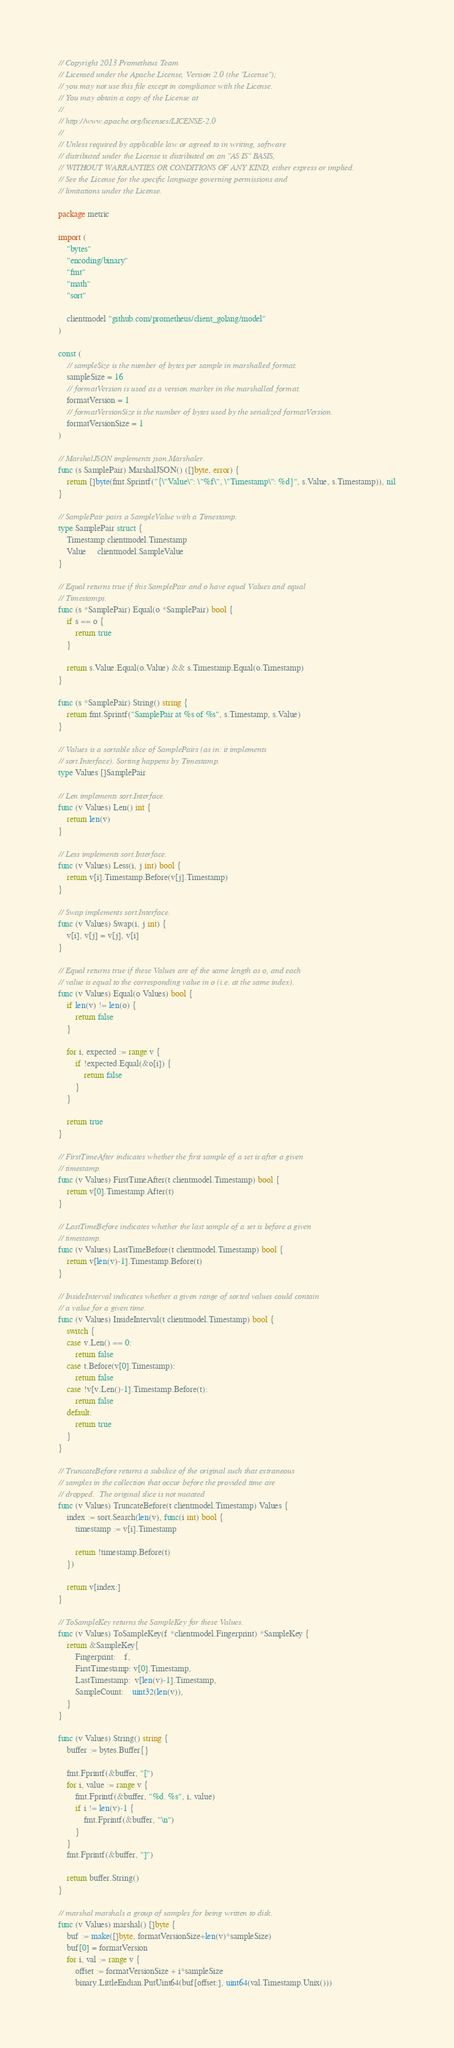<code> <loc_0><loc_0><loc_500><loc_500><_Go_>// Copyright 2013 Prometheus Team
// Licensed under the Apache License, Version 2.0 (the "License");
// you may not use this file except in compliance with the License.
// You may obtain a copy of the License at
//
// http://www.apache.org/licenses/LICENSE-2.0
//
// Unless required by applicable law or agreed to in writing, software
// distributed under the License is distributed on an "AS IS" BASIS,
// WITHOUT WARRANTIES OR CONDITIONS OF ANY KIND, either express or implied.
// See the License for the specific language governing permissions and
// limitations under the License.

package metric

import (
	"bytes"
	"encoding/binary"
	"fmt"
	"math"
	"sort"

	clientmodel "github.com/prometheus/client_golang/model"
)

const (
	// sampleSize is the number of bytes per sample in marshalled format.
	sampleSize = 16
	// formatVersion is used as a version marker in the marshalled format.
	formatVersion = 1
	// formatVersionSize is the number of bytes used by the serialized formatVersion.
	formatVersionSize = 1
)

// MarshalJSON implements json.Marshaler.
func (s SamplePair) MarshalJSON() ([]byte, error) {
	return []byte(fmt.Sprintf("{\"Value\": \"%f\", \"Timestamp\": %d}", s.Value, s.Timestamp)), nil
}

// SamplePair pairs a SampleValue with a Timestamp.
type SamplePair struct {
	Timestamp clientmodel.Timestamp
	Value     clientmodel.SampleValue
}

// Equal returns true if this SamplePair and o have equal Values and equal
// Timestamps.
func (s *SamplePair) Equal(o *SamplePair) bool {
	if s == o {
		return true
	}

	return s.Value.Equal(o.Value) && s.Timestamp.Equal(o.Timestamp)
}

func (s *SamplePair) String() string {
	return fmt.Sprintf("SamplePair at %s of %s", s.Timestamp, s.Value)
}

// Values is a sortable slice of SamplePairs (as in: it implements
// sort.Interface). Sorting happens by Timestamp.
type Values []SamplePair

// Len implements sort.Interface.
func (v Values) Len() int {
	return len(v)
}

// Less implements sort.Interface.
func (v Values) Less(i, j int) bool {
	return v[i].Timestamp.Before(v[j].Timestamp)
}

// Swap implements sort.Interface.
func (v Values) Swap(i, j int) {
	v[i], v[j] = v[j], v[i]
}

// Equal returns true if these Values are of the same length as o, and each
// value is equal to the corresponding value in o (i.e. at the same index).
func (v Values) Equal(o Values) bool {
	if len(v) != len(o) {
		return false
	}

	for i, expected := range v {
		if !expected.Equal(&o[i]) {
			return false
		}
	}

	return true
}

// FirstTimeAfter indicates whether the first sample of a set is after a given
// timestamp.
func (v Values) FirstTimeAfter(t clientmodel.Timestamp) bool {
	return v[0].Timestamp.After(t)
}

// LastTimeBefore indicates whether the last sample of a set is before a given
// timestamp.
func (v Values) LastTimeBefore(t clientmodel.Timestamp) bool {
	return v[len(v)-1].Timestamp.Before(t)
}

// InsideInterval indicates whether a given range of sorted values could contain
// a value for a given time.
func (v Values) InsideInterval(t clientmodel.Timestamp) bool {
	switch {
	case v.Len() == 0:
		return false
	case t.Before(v[0].Timestamp):
		return false
	case !v[v.Len()-1].Timestamp.Before(t):
		return false
	default:
		return true
	}
}

// TruncateBefore returns a subslice of the original such that extraneous
// samples in the collection that occur before the provided time are
// dropped.  The original slice is not mutated
func (v Values) TruncateBefore(t clientmodel.Timestamp) Values {
	index := sort.Search(len(v), func(i int) bool {
		timestamp := v[i].Timestamp

		return !timestamp.Before(t)
	})

	return v[index:]
}

// ToSampleKey returns the SampleKey for these Values.
func (v Values) ToSampleKey(f *clientmodel.Fingerprint) *SampleKey {
	return &SampleKey{
		Fingerprint:    f,
		FirstTimestamp: v[0].Timestamp,
		LastTimestamp:  v[len(v)-1].Timestamp,
		SampleCount:    uint32(len(v)),
	}
}

func (v Values) String() string {
	buffer := bytes.Buffer{}

	fmt.Fprintf(&buffer, "[")
	for i, value := range v {
		fmt.Fprintf(&buffer, "%d. %s", i, value)
		if i != len(v)-1 {
			fmt.Fprintf(&buffer, "\n")
		}
	}
	fmt.Fprintf(&buffer, "]")

	return buffer.String()
}

// marshal marshals a group of samples for being written to disk.
func (v Values) marshal() []byte {
	buf := make([]byte, formatVersionSize+len(v)*sampleSize)
	buf[0] = formatVersion
	for i, val := range v {
		offset := formatVersionSize + i*sampleSize
		binary.LittleEndian.PutUint64(buf[offset:], uint64(val.Timestamp.Unix()))</code> 